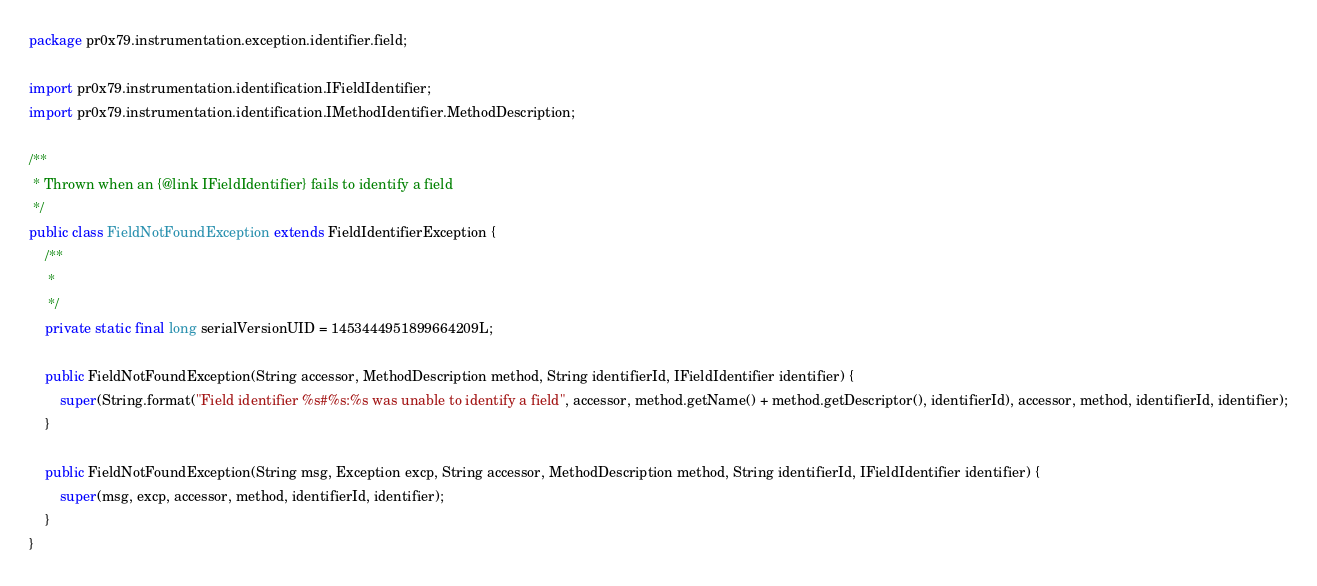<code> <loc_0><loc_0><loc_500><loc_500><_Java_>package pr0x79.instrumentation.exception.identifier.field;

import pr0x79.instrumentation.identification.IFieldIdentifier;
import pr0x79.instrumentation.identification.IMethodIdentifier.MethodDescription;

/**
 * Thrown when an {@link IFieldIdentifier} fails to identify a field
 */
public class FieldNotFoundException extends FieldIdentifierException {
	/**
	 * 
	 */
	private static final long serialVersionUID = 1453444951899664209L;

	public FieldNotFoundException(String accessor, MethodDescription method, String identifierId, IFieldIdentifier identifier) {
		super(String.format("Field identifier %s#%s:%s was unable to identify a field", accessor, method.getName() + method.getDescriptor(), identifierId), accessor, method, identifierId, identifier);
	}

	public FieldNotFoundException(String msg, Exception excp, String accessor, MethodDescription method, String identifierId, IFieldIdentifier identifier) {
		super(msg, excp, accessor, method, identifierId, identifier);
	}
}
</code> 